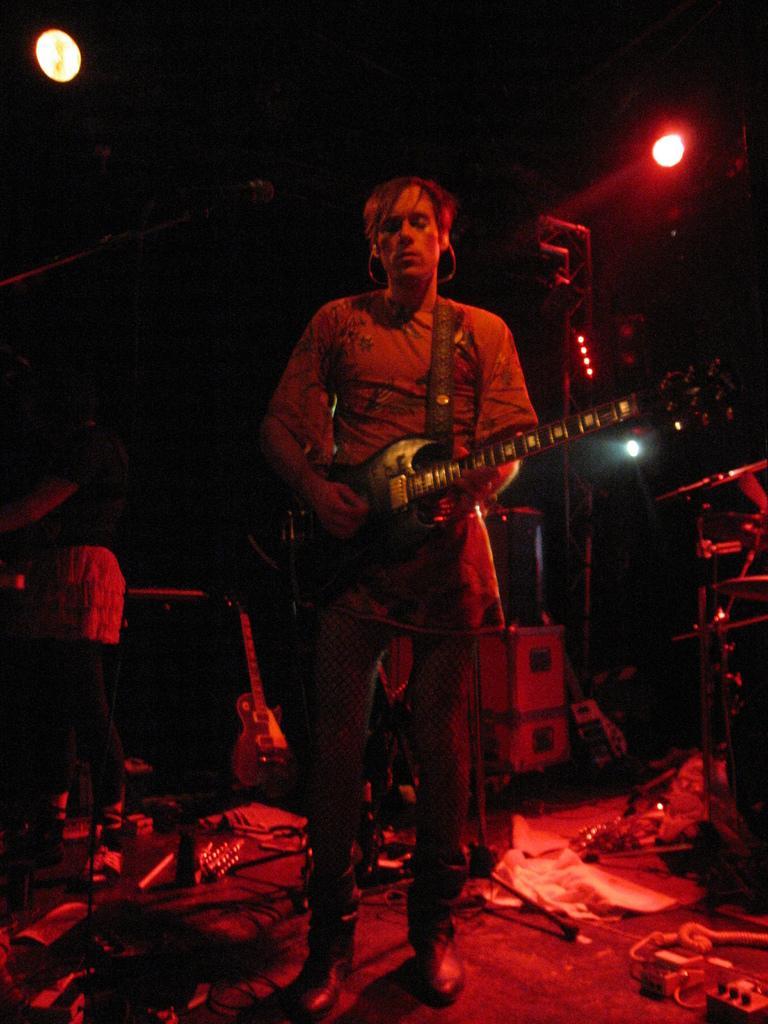In one or two sentences, can you explain what this image depicts? In this image I can see two persons are standing and in the front I can see one of them is holding a guitar. In the background I can see one more guitar, few stuffs on the floor and three lights. I can also see this image is little bit in dark. 